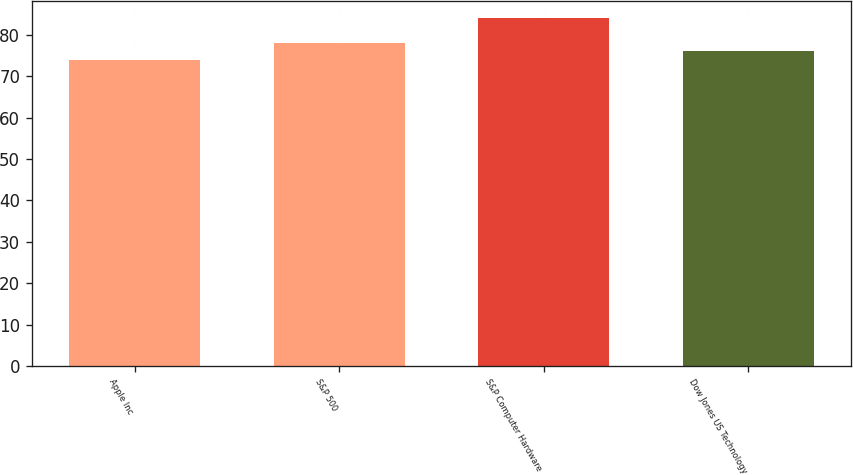Convert chart. <chart><loc_0><loc_0><loc_500><loc_500><bar_chart><fcel>Apple Inc<fcel>S&P 500<fcel>S&P Computer Hardware<fcel>Dow Jones US Technology<nl><fcel>74<fcel>78<fcel>84<fcel>76<nl></chart> 